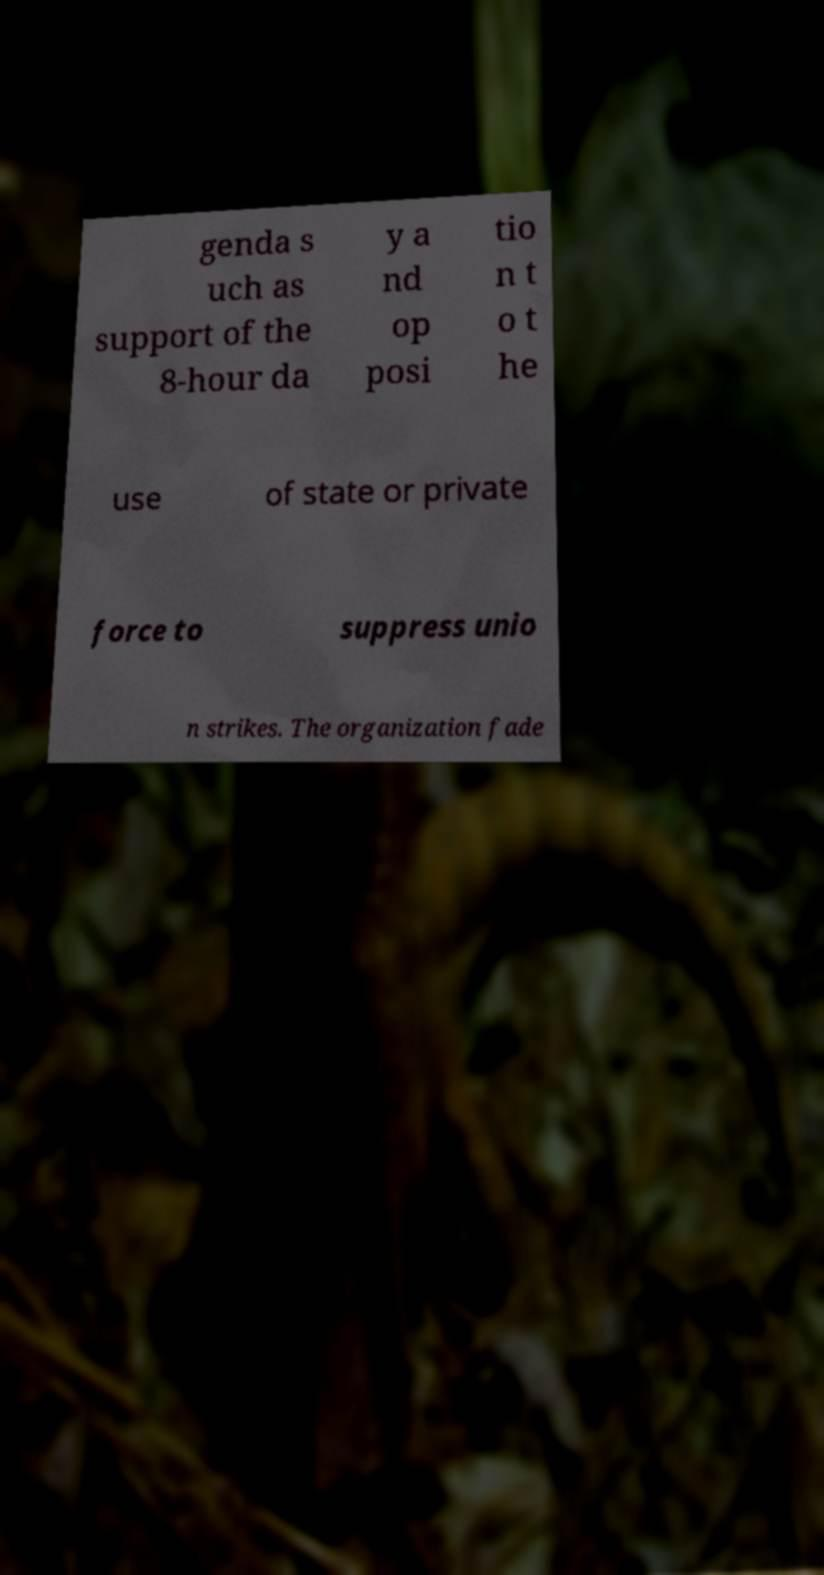Can you read and provide the text displayed in the image?This photo seems to have some interesting text. Can you extract and type it out for me? genda s uch as support of the 8-hour da y a nd op posi tio n t o t he use of state or private force to suppress unio n strikes. The organization fade 